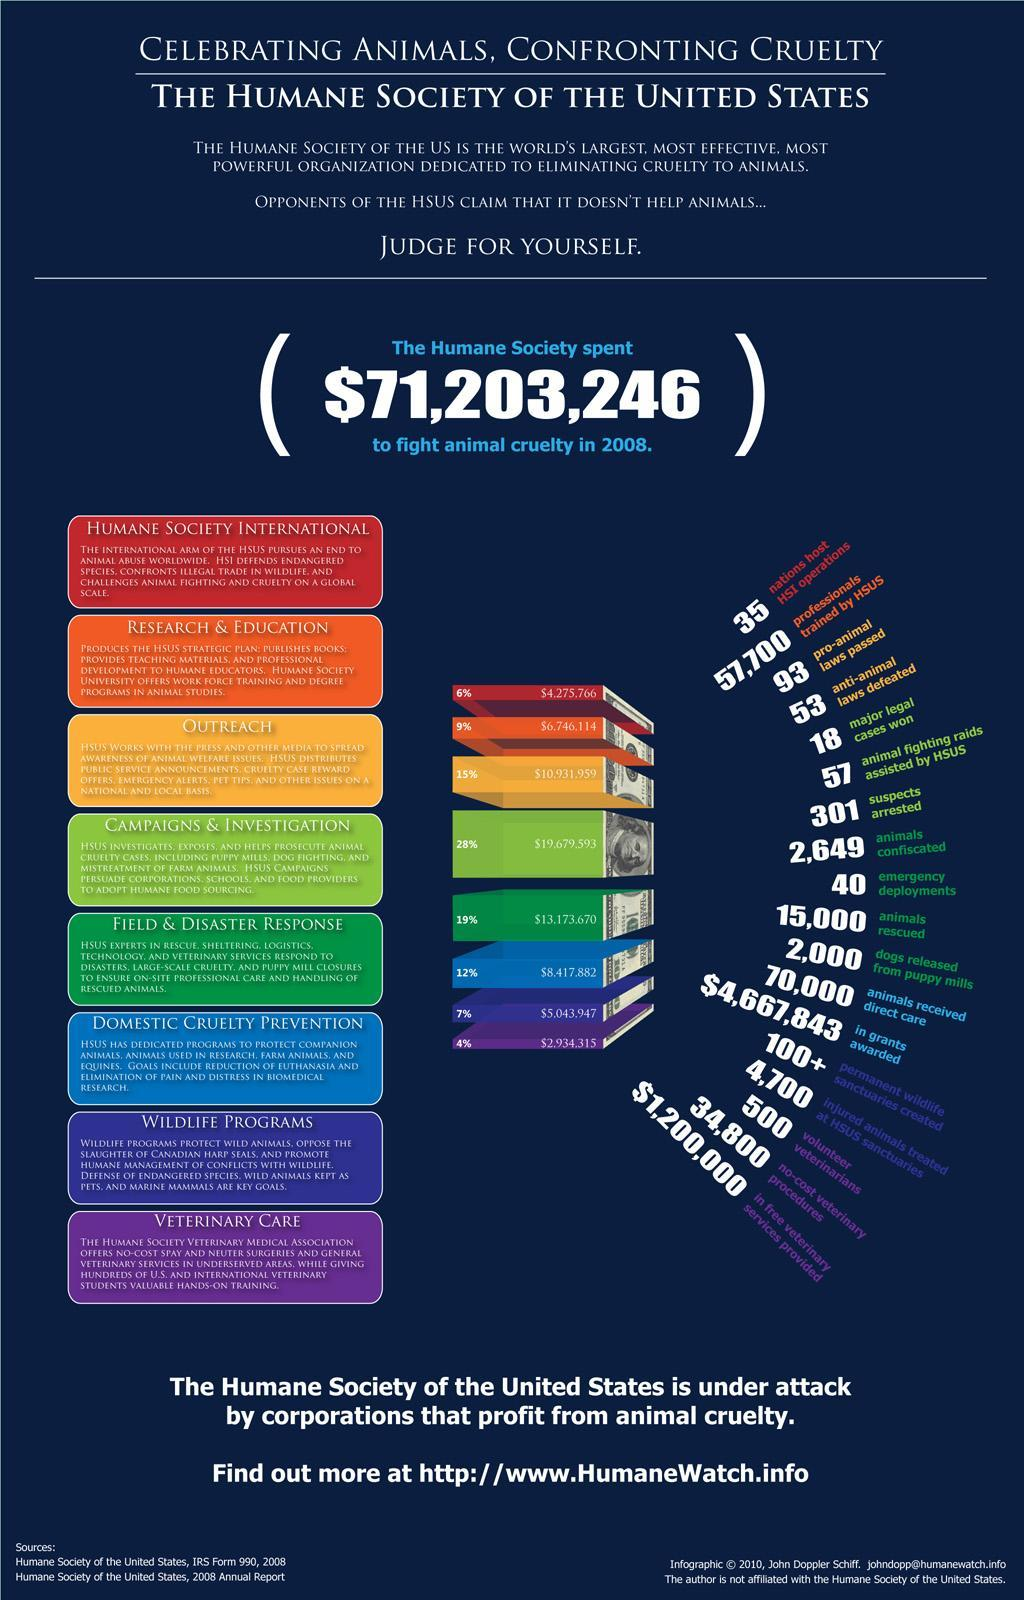For which activitiy 28% of money has been spent?
Answer the question with a short phrase. CAMPAIGNS & INVESTIGATION 